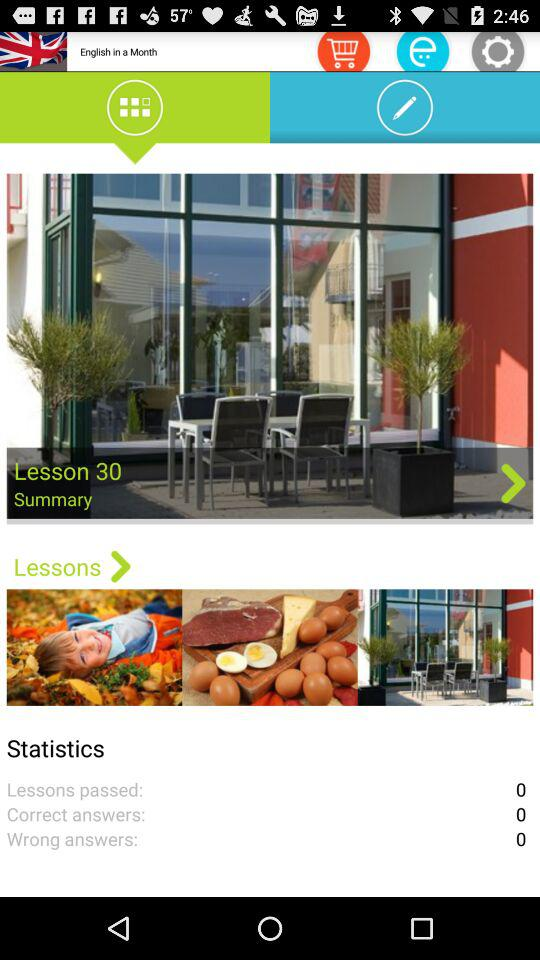What is the summary of lesson 29?
When the provided information is insufficient, respond with <no answer>. <no answer> 